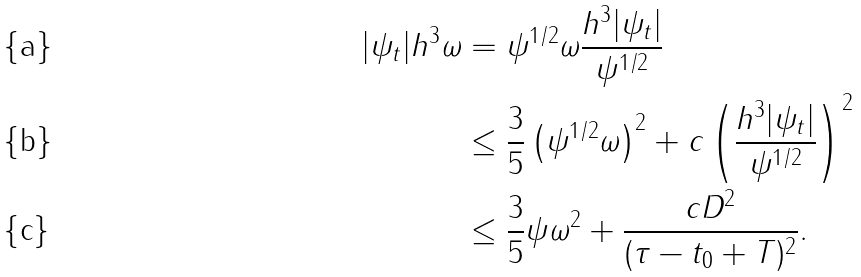<formula> <loc_0><loc_0><loc_500><loc_500>| \psi _ { t } | h ^ { 3 } \omega & = \psi ^ { 1 / 2 } \omega \frac { h ^ { 3 } | \psi _ { t } | } { \psi ^ { 1 / 2 } } \\ & \leq \frac { 3 } { 5 } \left ( \psi ^ { 1 / 2 } \omega \right ) ^ { 2 } + c \left ( \frac { h ^ { 3 } | \psi _ { t } | } { \psi ^ { 1 / 2 } } \right ) ^ { 2 } \\ & \leq \frac { 3 } { 5 } \psi \omega ^ { 2 } + \frac { c D ^ { 2 } } { ( \tau - t _ { 0 } + T ) ^ { 2 } } .</formula> 